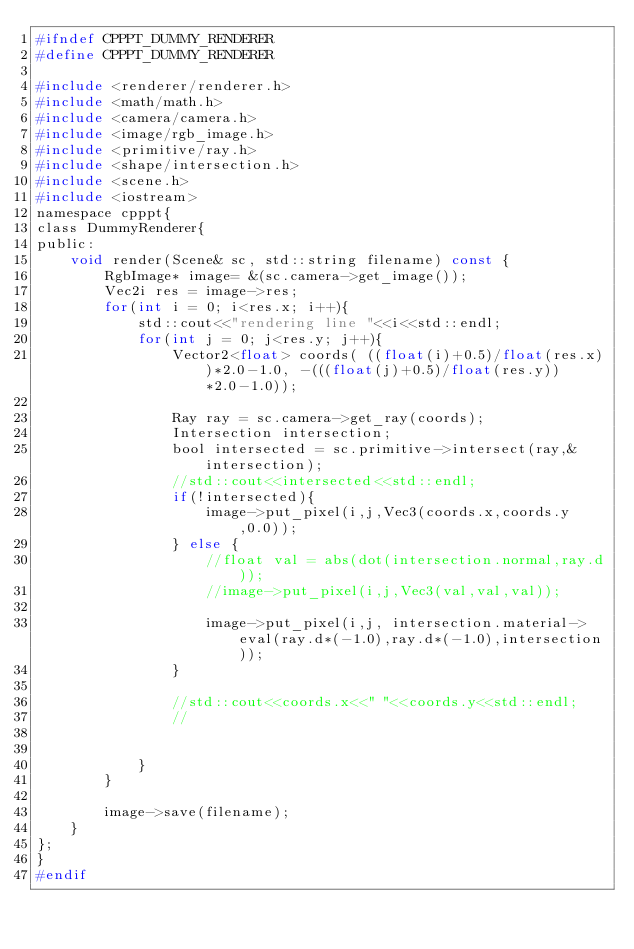<code> <loc_0><loc_0><loc_500><loc_500><_C_>#ifndef CPPPT_DUMMY_RENDERER
#define CPPPT_DUMMY_RENDERER

#include <renderer/renderer.h>
#include <math/math.h>
#include <camera/camera.h>
#include <image/rgb_image.h>
#include <primitive/ray.h>
#include <shape/intersection.h>
#include <scene.h>
#include <iostream>
namespace cpppt{
class DummyRenderer{
public:
    void render(Scene& sc, std::string filename) const {
        RgbImage* image= &(sc.camera->get_image());
        Vec2i res = image->res;
        for(int i = 0; i<res.x; i++){
            std::cout<<"rendering line "<<i<<std::endl;
            for(int j = 0; j<res.y; j++){
                Vector2<float> coords( ((float(i)+0.5)/float(res.x))*2.0-1.0, -(((float(j)+0.5)/float(res.y))*2.0-1.0));

                Ray ray = sc.camera->get_ray(coords);
                Intersection intersection;
                bool intersected = sc.primitive->intersect(ray,&intersection);
                //std::cout<<intersected<<std::endl;
                if(!intersected){
                    image->put_pixel(i,j,Vec3(coords.x,coords.y,0.0));
                } else {
                    //float val = abs(dot(intersection.normal,ray.d));
                    //image->put_pixel(i,j,Vec3(val,val,val));

                    image->put_pixel(i,j, intersection.material->eval(ray.d*(-1.0),ray.d*(-1.0),intersection));
                }

                //std::cout<<coords.x<<" "<<coords.y<<std::endl;
                //


            }
        }

        image->save(filename);
    }
};
}
#endif</code> 